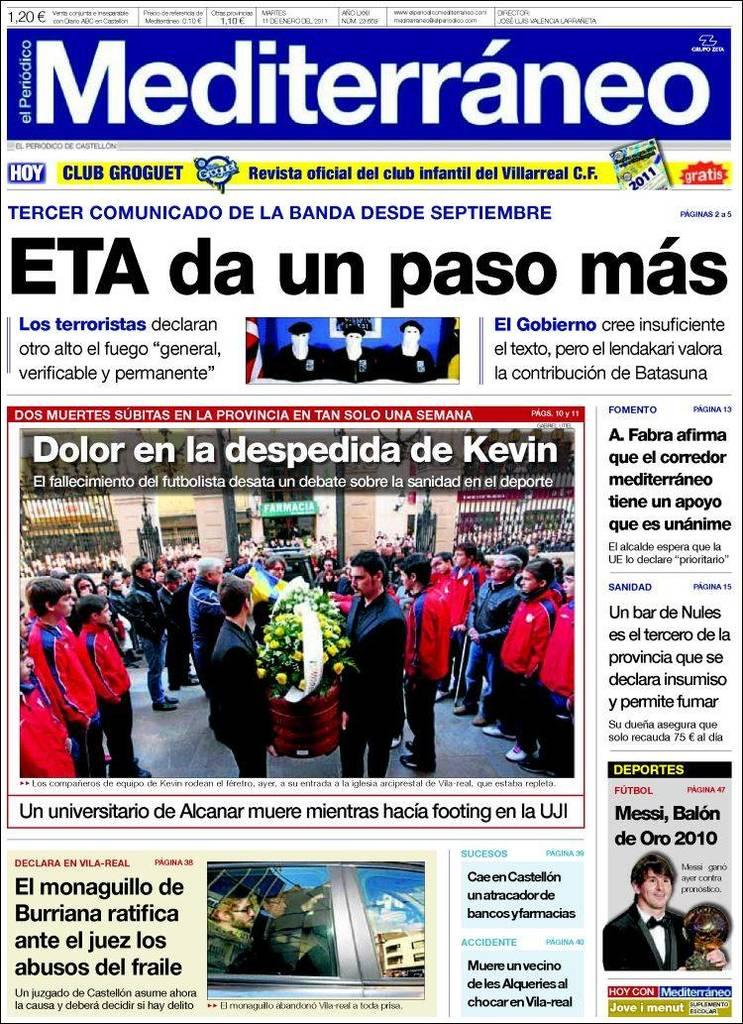What can be observed about the nature of the image? The image is edited. What other elements are present in the image besides the edited content? There is text and images of a person in the image. What type of beast can be seen walking on the sidewalk in the image? There is no beast or sidewalk present in the image; it features edited content, text, and images of a person. 